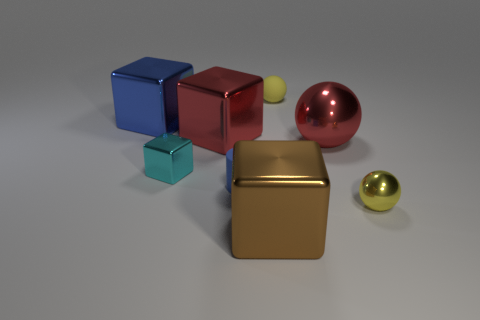Add 1 large red shiny objects. How many objects exist? 9 Subtract all cylinders. How many objects are left? 7 Subtract all tiny metallic blocks. Subtract all shiny spheres. How many objects are left? 5 Add 6 large red things. How many large red things are left? 8 Add 7 big yellow rubber cylinders. How many big yellow rubber cylinders exist? 7 Subtract 0 green balls. How many objects are left? 8 